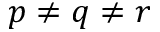<formula> <loc_0><loc_0><loc_500><loc_500>p \neq q \neq r</formula> 